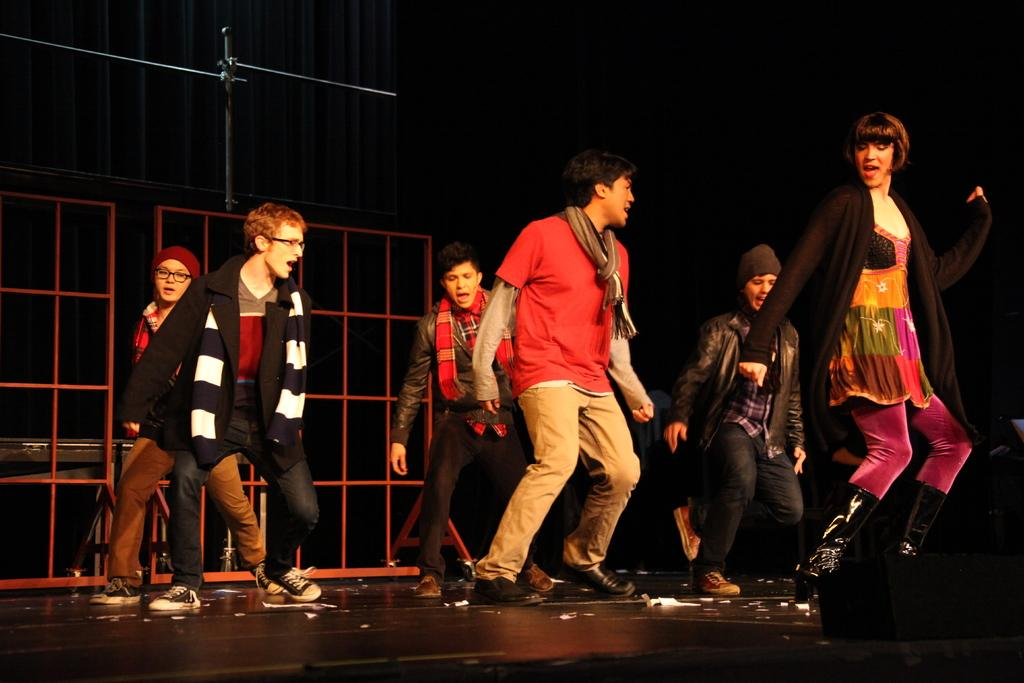What is the main subject in the foreground of the image? There is a stage in the foreground of the image. What are the people on the stage doing? People are performing a dance on the stage. What can be seen on the left side of the image? There is a stand, a fence, and a table on the left side of the image. How would you describe the background of the image? The background of the image is dark. How many jellyfish are swimming in the background of the image? There are no jellyfish present in the image; the background is dark. What type of eggs can be seen on the table in the image? There are no eggs visible on the table in the image. 